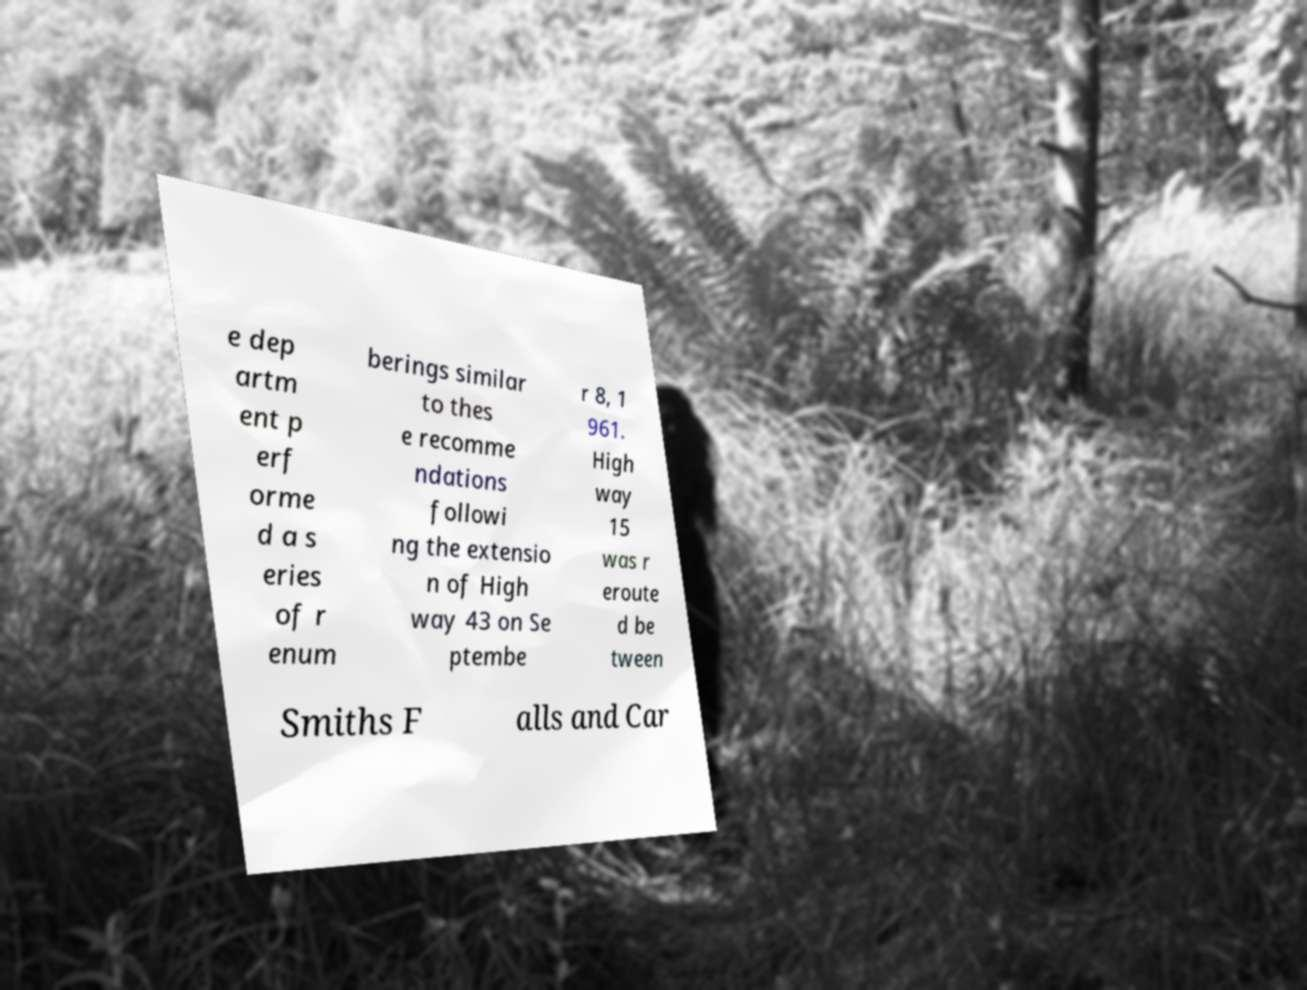Please identify and transcribe the text found in this image. e dep artm ent p erf orme d a s eries of r enum berings similar to thes e recomme ndations followi ng the extensio n of High way 43 on Se ptembe r 8, 1 961. High way 15 was r eroute d be tween Smiths F alls and Car 